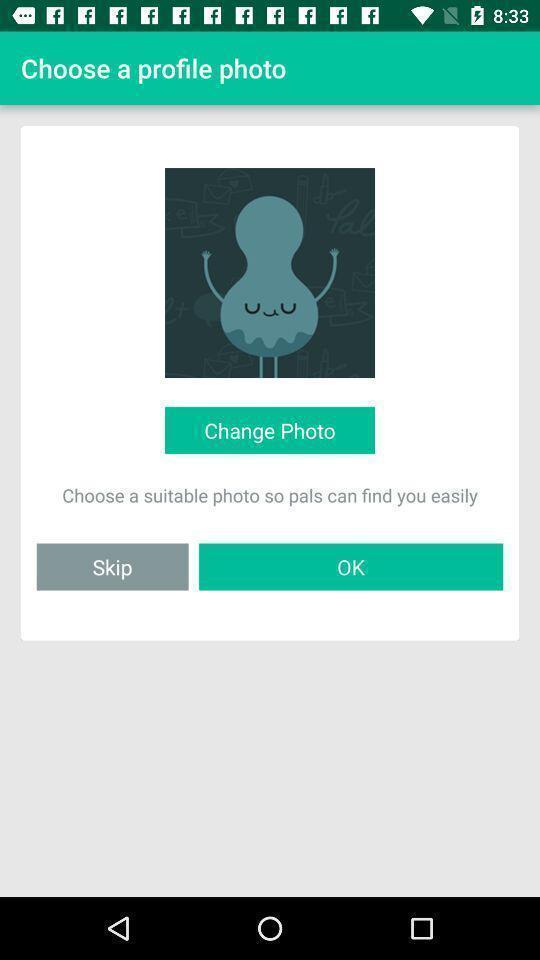What is the overall content of this screenshot? Screen asking to choose a profile photo. 